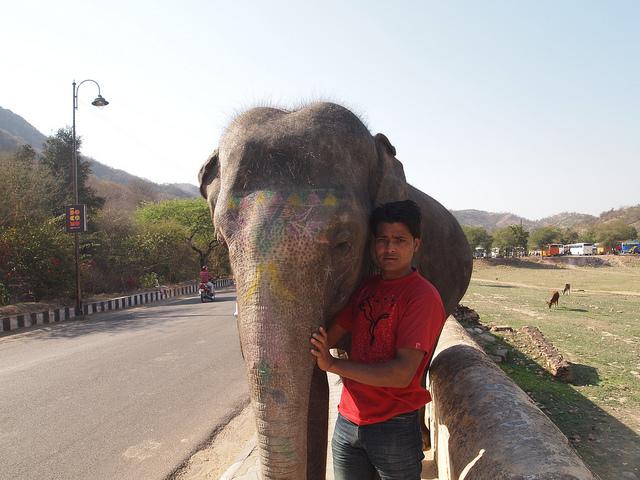Are these animals good workers?
Concise answer only. Yes. Is this an urban area?
Concise answer only. No. Is this a circus elephant?
Keep it brief. No. 